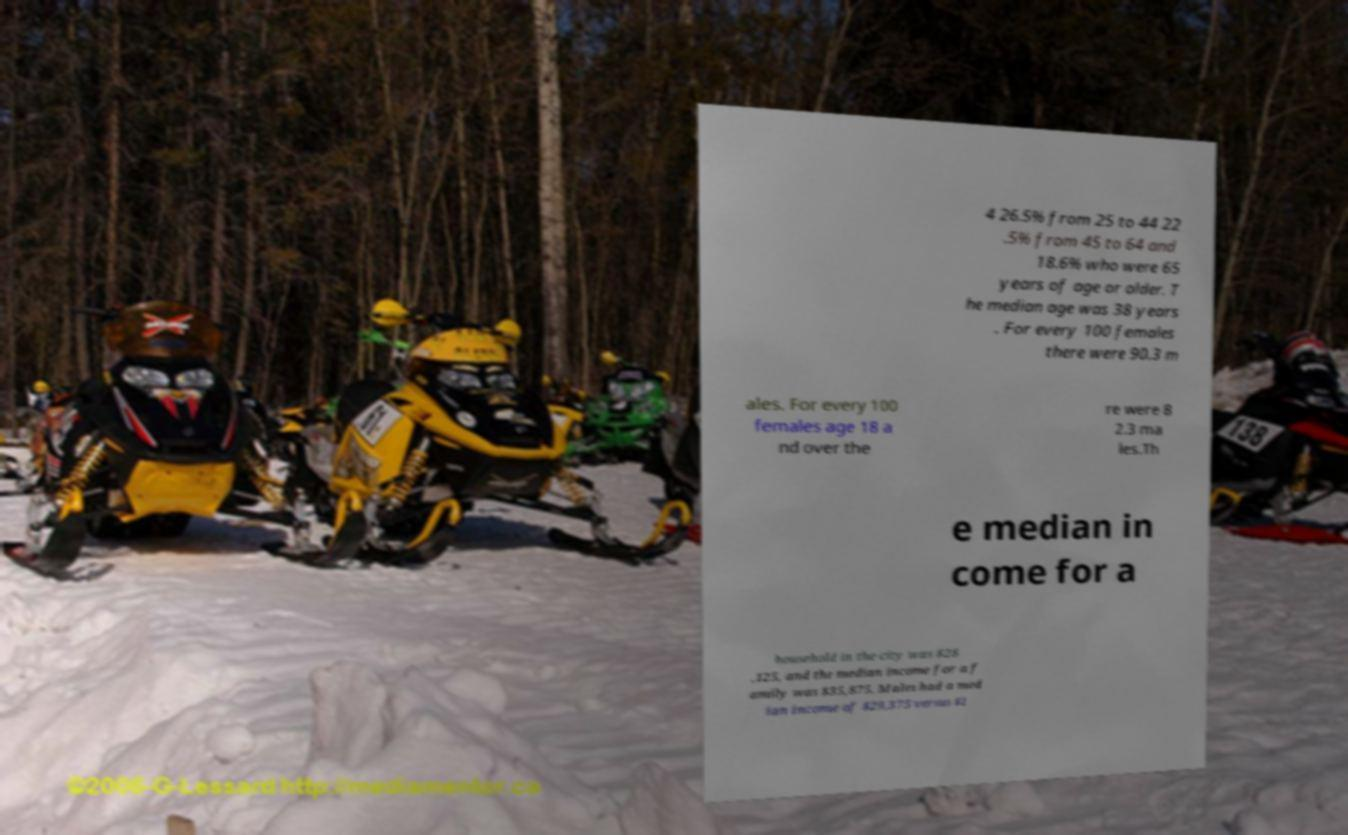Can you read and provide the text displayed in the image?This photo seems to have some interesting text. Can you extract and type it out for me? 4 26.5% from 25 to 44 22 .5% from 45 to 64 and 18.6% who were 65 years of age or older. T he median age was 38 years . For every 100 females there were 90.3 m ales. For every 100 females age 18 a nd over the re were 8 2.3 ma les.Th e median in come for a household in the city was $28 ,125, and the median income for a f amily was $35,875. Males had a med ian income of $29,375 versus $1 